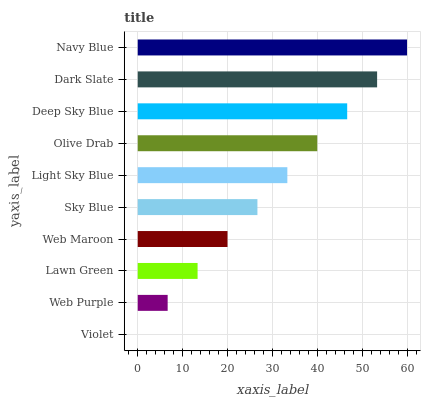Is Violet the minimum?
Answer yes or no. Yes. Is Navy Blue the maximum?
Answer yes or no. Yes. Is Web Purple the minimum?
Answer yes or no. No. Is Web Purple the maximum?
Answer yes or no. No. Is Web Purple greater than Violet?
Answer yes or no. Yes. Is Violet less than Web Purple?
Answer yes or no. Yes. Is Violet greater than Web Purple?
Answer yes or no. No. Is Web Purple less than Violet?
Answer yes or no. No. Is Light Sky Blue the high median?
Answer yes or no. Yes. Is Sky Blue the low median?
Answer yes or no. Yes. Is Deep Sky Blue the high median?
Answer yes or no. No. Is Web Maroon the low median?
Answer yes or no. No. 